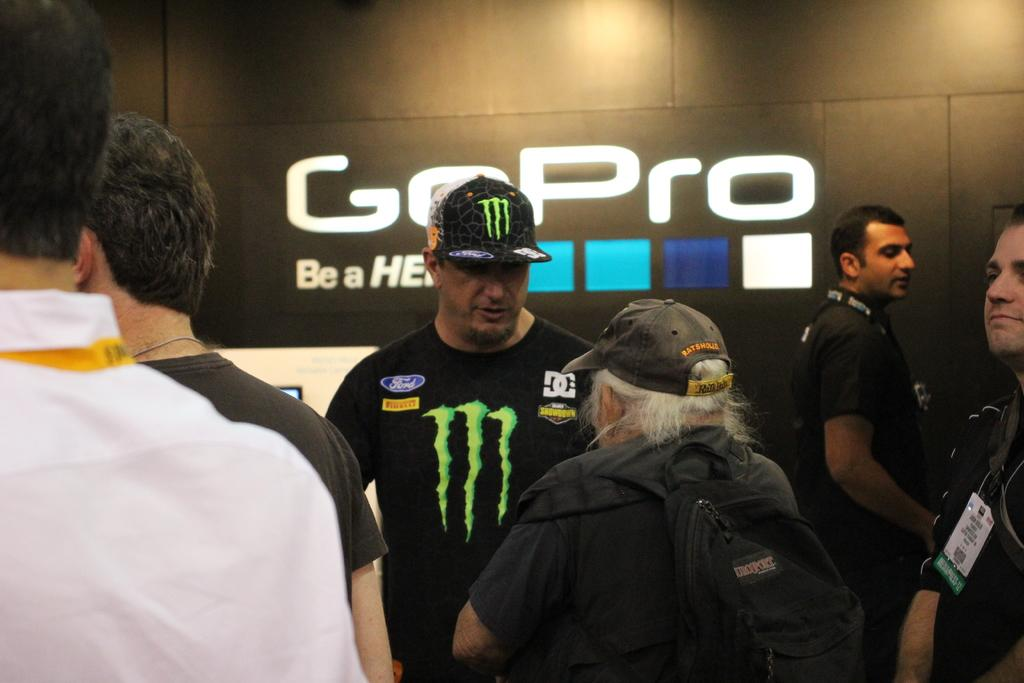<image>
Render a clear and concise summary of the photo. A man in a Monster t-shirt standing in front of a wall with the word GoPro on it. 